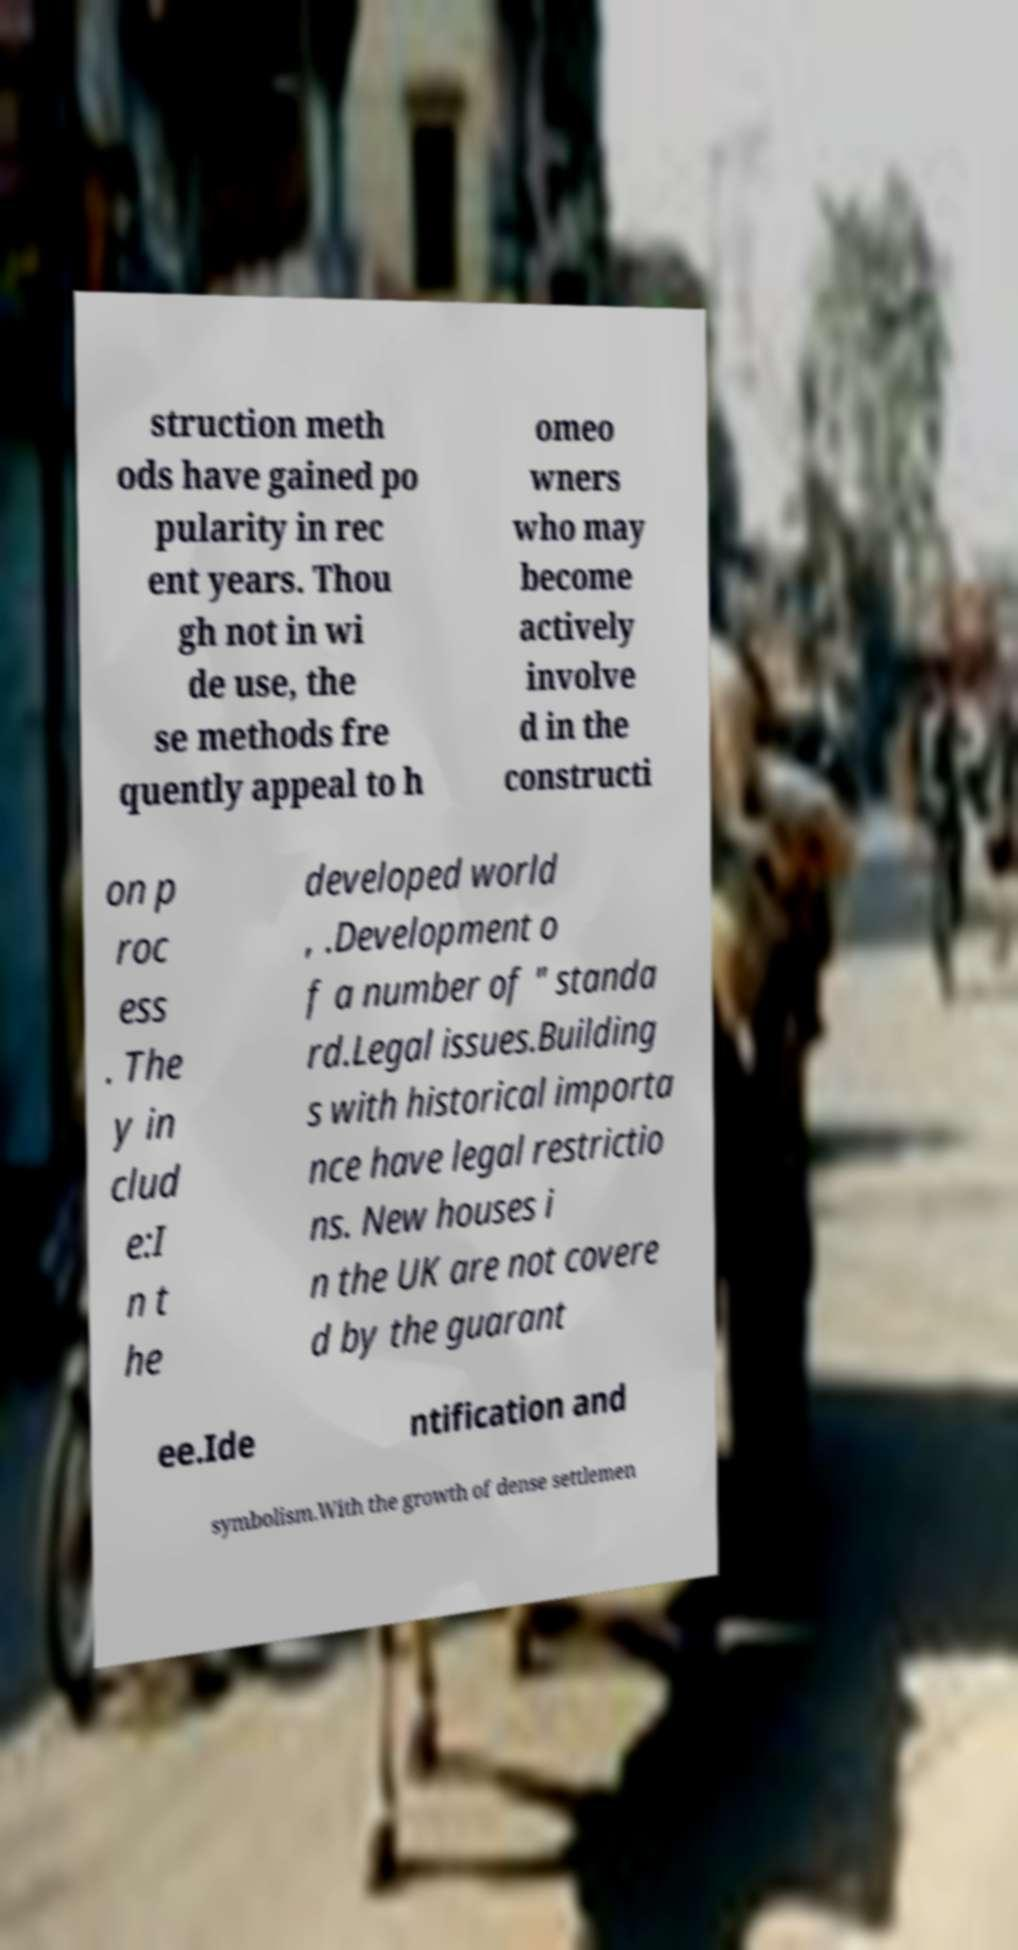Could you extract and type out the text from this image? struction meth ods have gained po pularity in rec ent years. Thou gh not in wi de use, the se methods fre quently appeal to h omeo wners who may become actively involve d in the constructi on p roc ess . The y in clud e:I n t he developed world , .Development o f a number of " standa rd.Legal issues.Building s with historical importa nce have legal restrictio ns. New houses i n the UK are not covere d by the guarant ee.Ide ntification and symbolism.With the growth of dense settlemen 